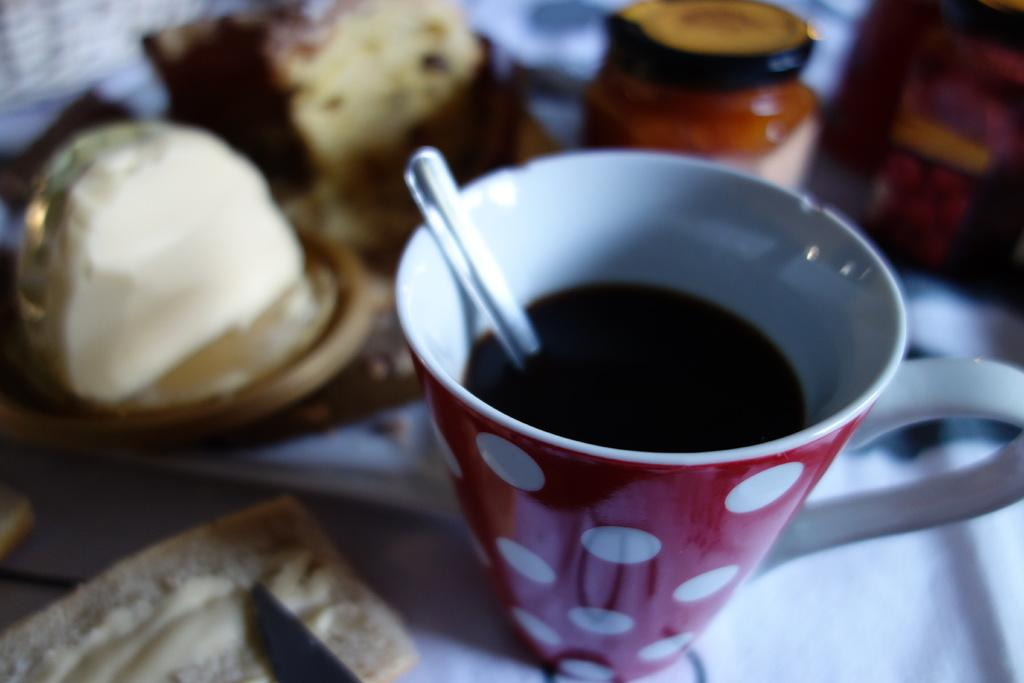What is located in the foreground of the image? There is a cup in the foreground of the image. What is inside the cup? There is a spoon and a drink in the cup. What type of food can be seen beside the cup? There are breads beside the cup. What other items are visible near the cup? There are bottles beside the cup. Can you describe any other objects visible in the image? Yes, there are other objects visible in the image. Can you tell me how many geese are visible in the image? There are no geese present in the image. What type of bottle is being requested by the goose in the image? There is no goose present in the image, and therefore no request for a bottle can be made. 